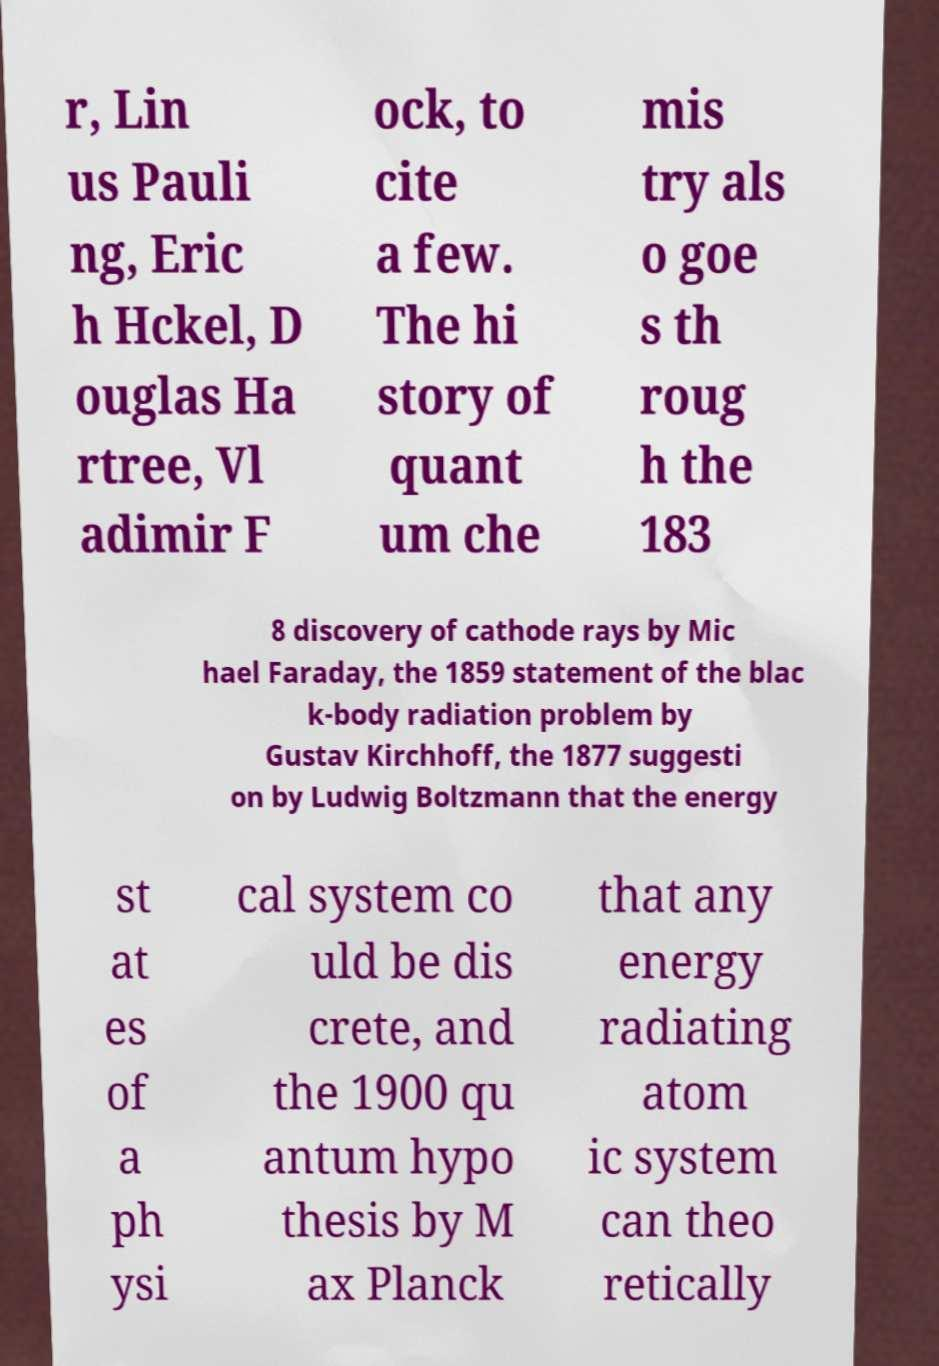Can you accurately transcribe the text from the provided image for me? r, Lin us Pauli ng, Eric h Hckel, D ouglas Ha rtree, Vl adimir F ock, to cite a few. The hi story of quant um che mis try als o goe s th roug h the 183 8 discovery of cathode rays by Mic hael Faraday, the 1859 statement of the blac k-body radiation problem by Gustav Kirchhoff, the 1877 suggesti on by Ludwig Boltzmann that the energy st at es of a ph ysi cal system co uld be dis crete, and the 1900 qu antum hypo thesis by M ax Planck that any energy radiating atom ic system can theo retically 